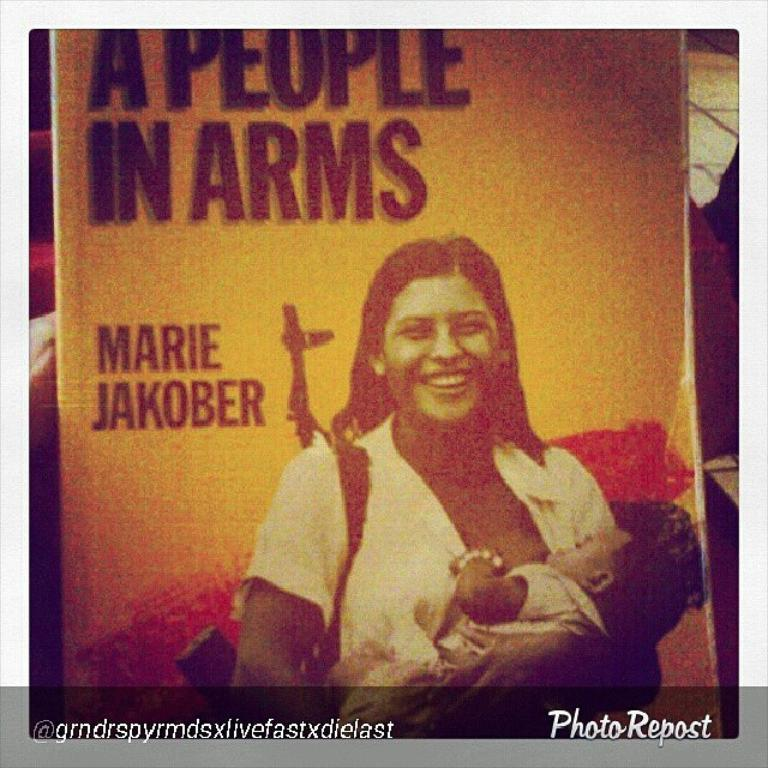What is the original subject of the image? The image is an edited version of a book. What can be seen on the book in the image? There is an image of a woman and a baby on the book. Is there any text on the book in the image? Yes, there is text written on the book. What additional elements can be observed on the image? Watermarks are present on the image. What color is the blood on the woman's shirt in the image? There is no blood present in the image; it features an image of a woman and a baby on a book. What type of drug is the woman holding in the image? There is no drug present in the image; it features an image of a woman and a baby on a book. 